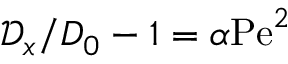<formula> <loc_0><loc_0><loc_500><loc_500>\mathcal { D } _ { x } / D _ { 0 } - 1 = \alpha P e ^ { 2 }</formula> 